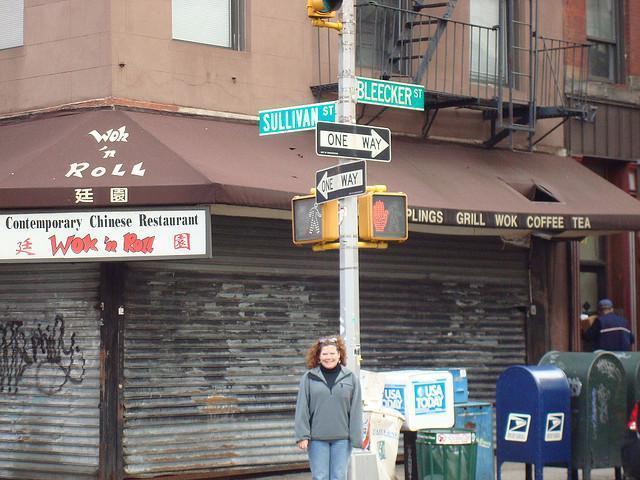How many traffic lights are in the picture?
Give a very brief answer. 1. How many people are there?
Give a very brief answer. 2. 